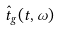Convert formula to latex. <formula><loc_0><loc_0><loc_500><loc_500>\hat { t } _ { g } ( t , \omega )</formula> 